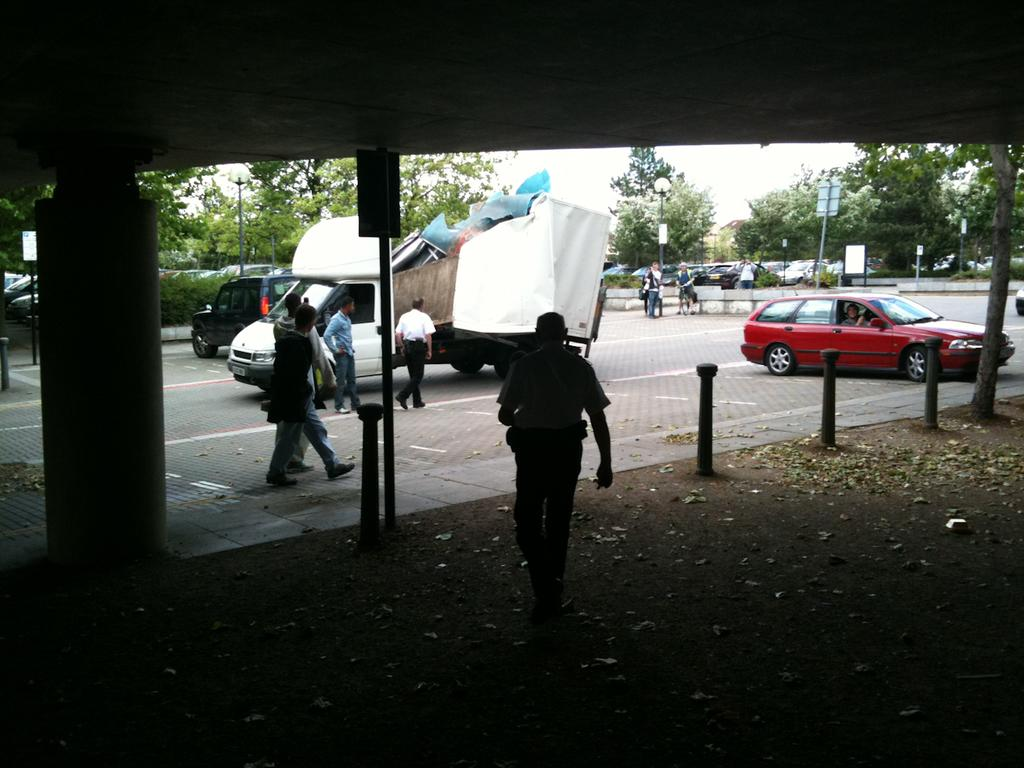What are the people in the image doing? The people in the image are walking. What vehicles are present in the image? There is a car and a truck in the image. Where are the car and truck located in the image? The car and truck are on the road in the image. What type of wax is being used by the farmer in the image? There is no farmer or wax present in the image. What type of pleasure can be seen being experienced by the people in the image? The image does not depict any specific emotions or pleasures being experienced by the people. 